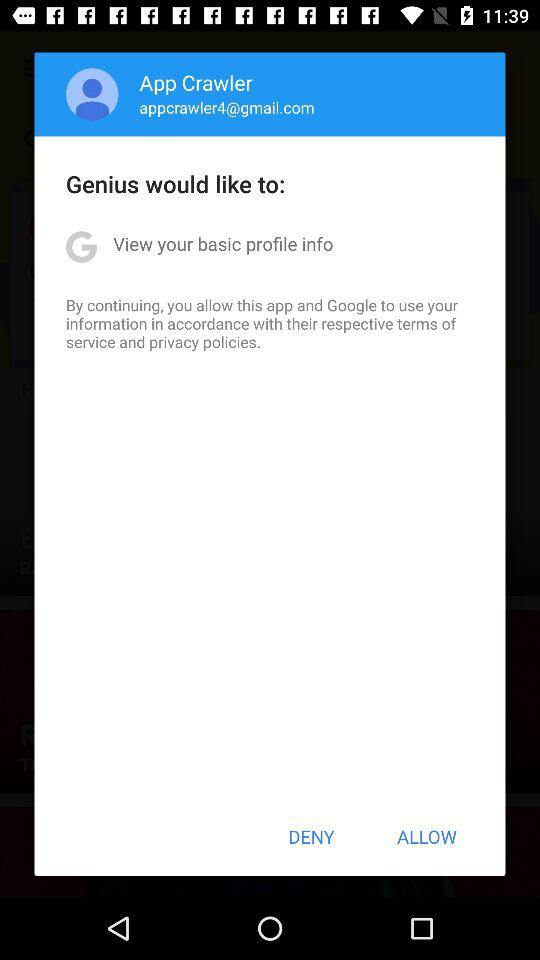What is the email address? The email address is appcrawler4@gmail.com. 